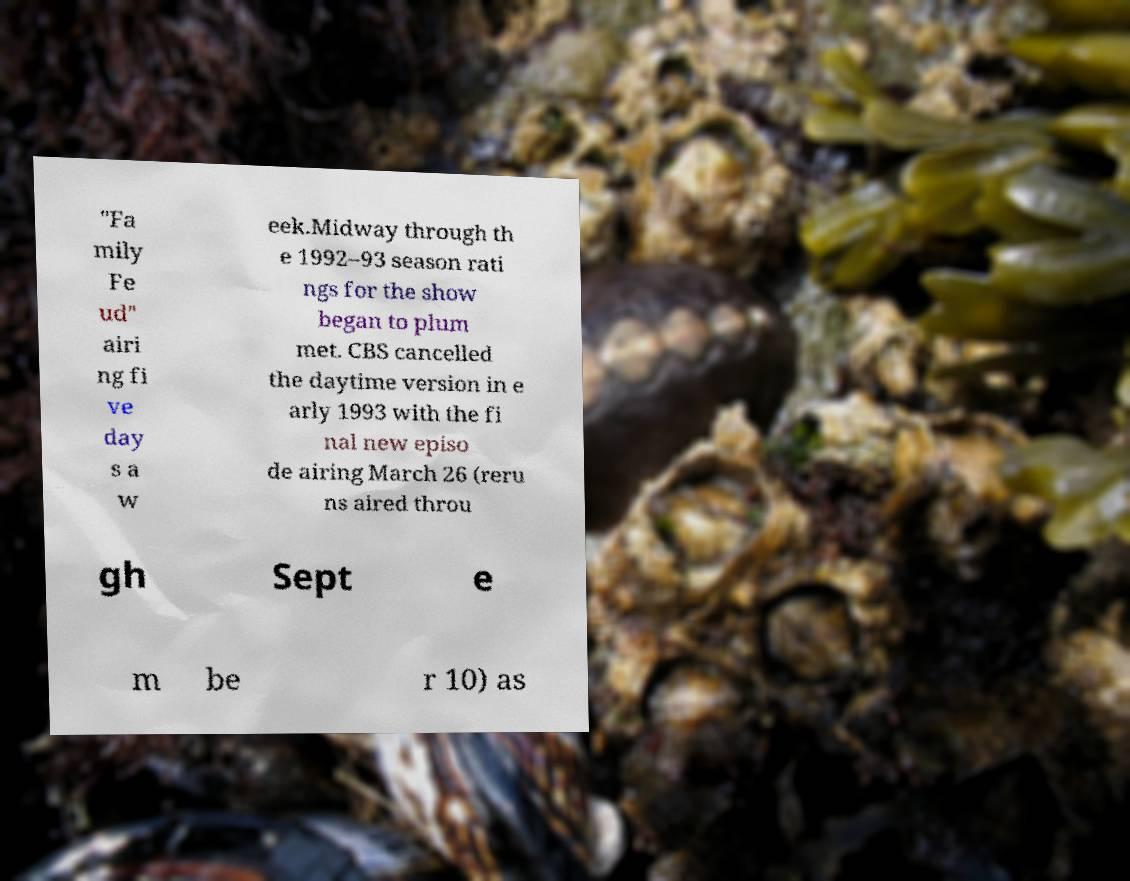Can you accurately transcribe the text from the provided image for me? "Fa mily Fe ud" airi ng fi ve day s a w eek.Midway through th e 1992–93 season rati ngs for the show began to plum met. CBS cancelled the daytime version in e arly 1993 with the fi nal new episo de airing March 26 (reru ns aired throu gh Sept e m be r 10) as 